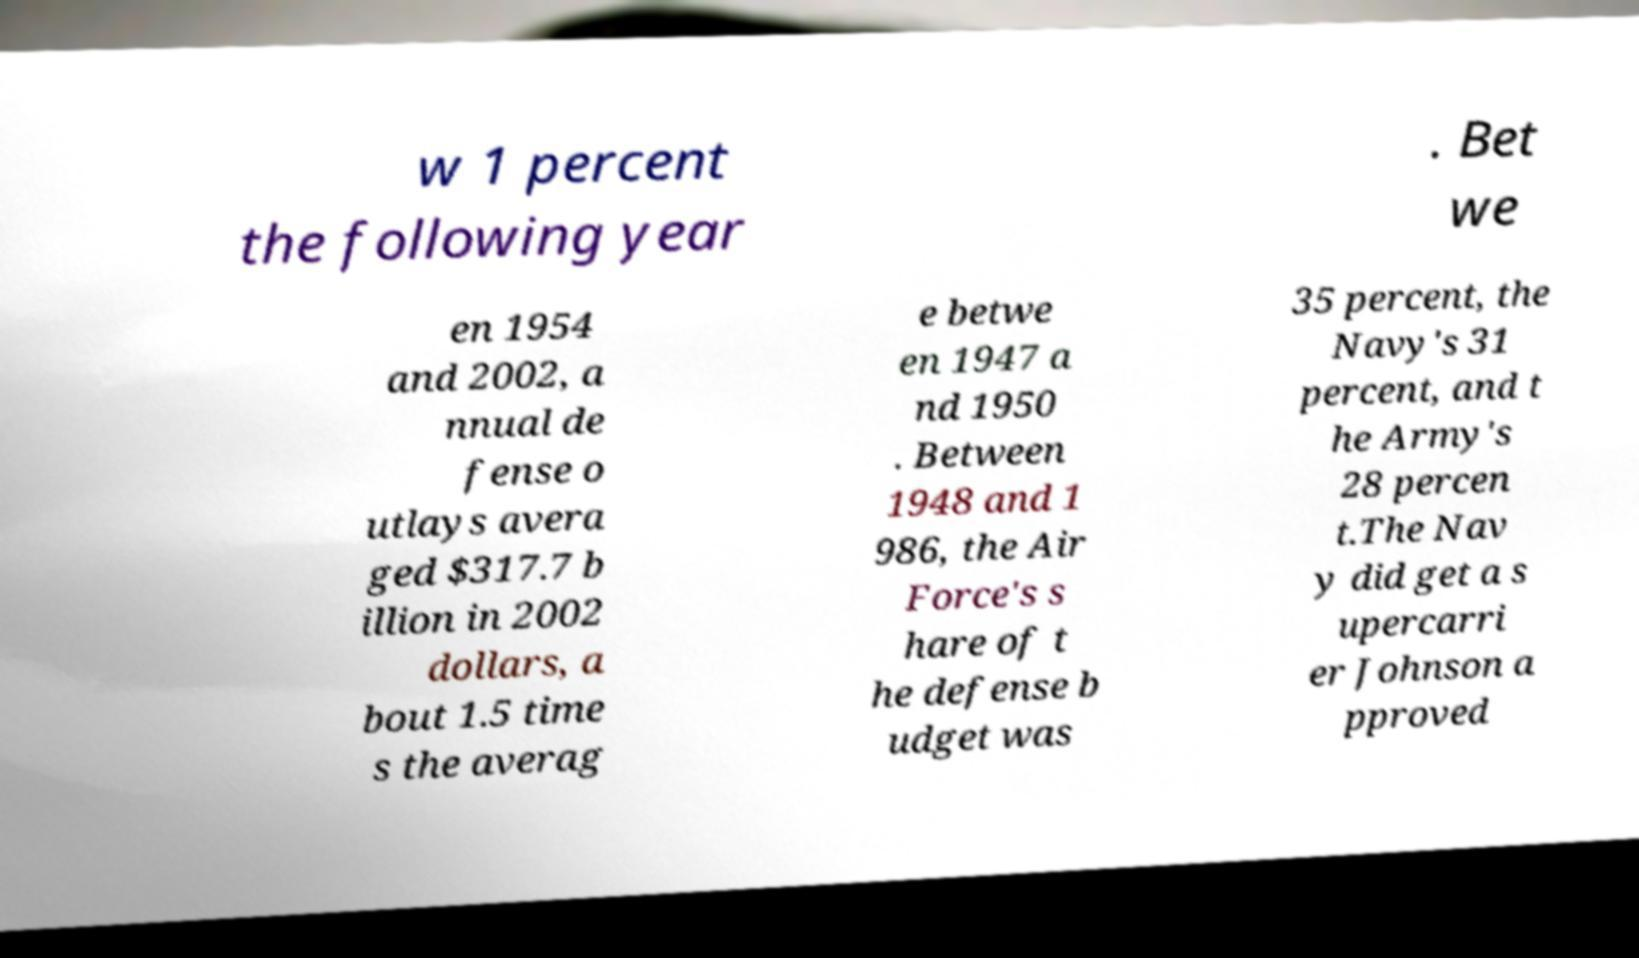Could you extract and type out the text from this image? w 1 percent the following year . Bet we en 1954 and 2002, a nnual de fense o utlays avera ged $317.7 b illion in 2002 dollars, a bout 1.5 time s the averag e betwe en 1947 a nd 1950 . Between 1948 and 1 986, the Air Force's s hare of t he defense b udget was 35 percent, the Navy's 31 percent, and t he Army's 28 percen t.The Nav y did get a s upercarri er Johnson a pproved 